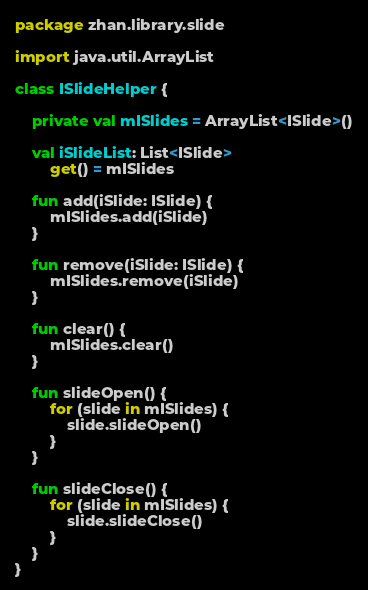Convert code to text. <code><loc_0><loc_0><loc_500><loc_500><_Kotlin_>package zhan.library.slide

import java.util.ArrayList

class ISlideHelper {

    private val mISlides = ArrayList<ISlide>()

    val iSlideList: List<ISlide>
        get() = mISlides

    fun add(iSlide: ISlide) {
        mISlides.add(iSlide)
    }

    fun remove(iSlide: ISlide) {
        mISlides.remove(iSlide)
    }

    fun clear() {
        mISlides.clear()
    }

    fun slideOpen() {
        for (slide in mISlides) {
            slide.slideOpen()
        }
    }

    fun slideClose() {
        for (slide in mISlides) {
            slide.slideClose()
        }
    }
}
</code> 